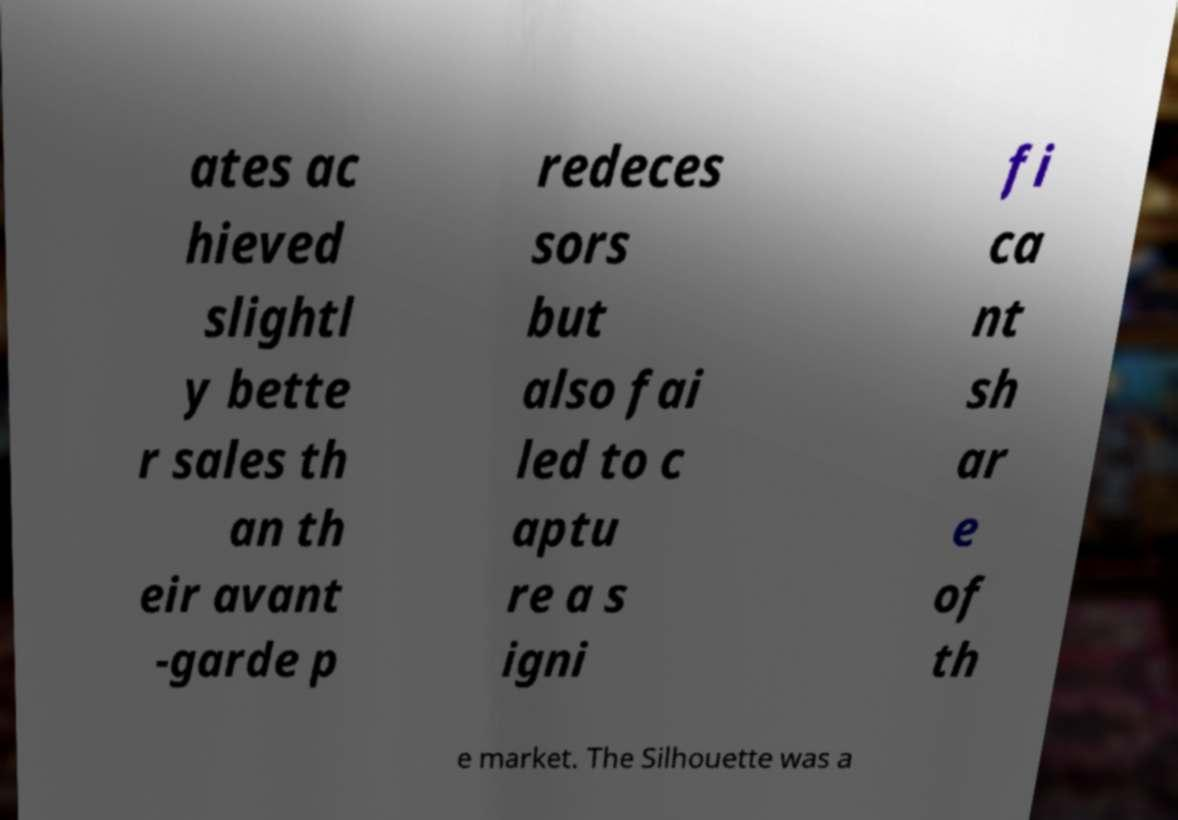Could you assist in decoding the text presented in this image and type it out clearly? ates ac hieved slightl y bette r sales th an th eir avant -garde p redeces sors but also fai led to c aptu re a s igni fi ca nt sh ar e of th e market. The Silhouette was a 